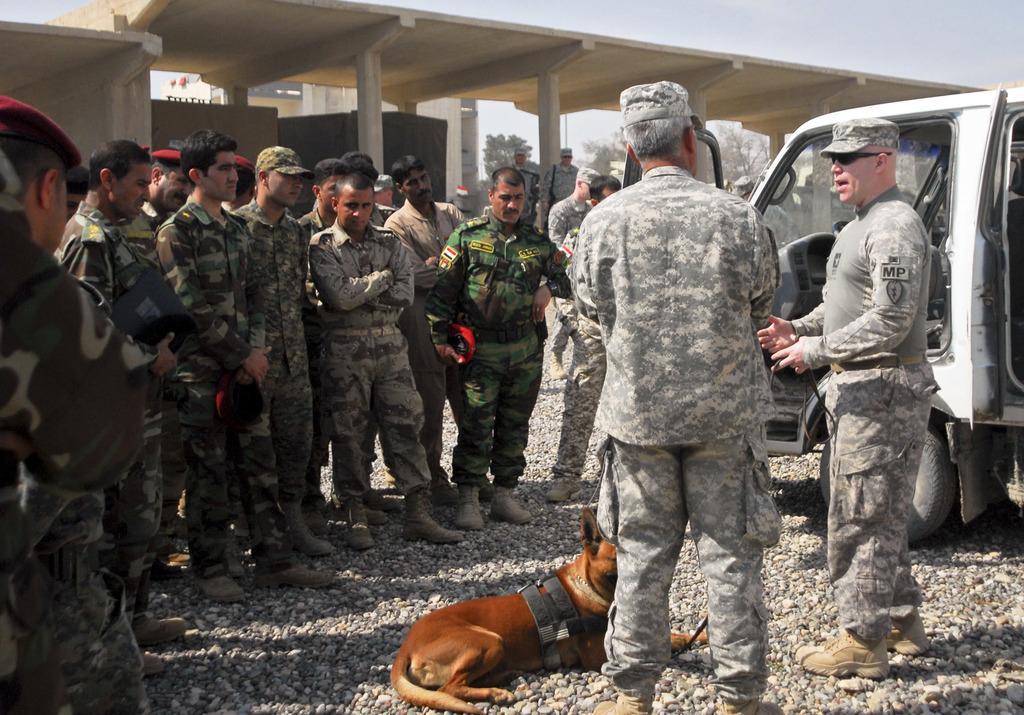Please provide a concise description of this image. On the left side, there are persons in uniforms, standing on the ground, on which there are stones. On the right side, there is a brown color dog lying on the ground, beside this dog, there are two persons in uniforms, one of them is speaking and there is a vehicle which is having one door opened. In the background, there are other person's, a bridge, trees, buildings and there is sky. 